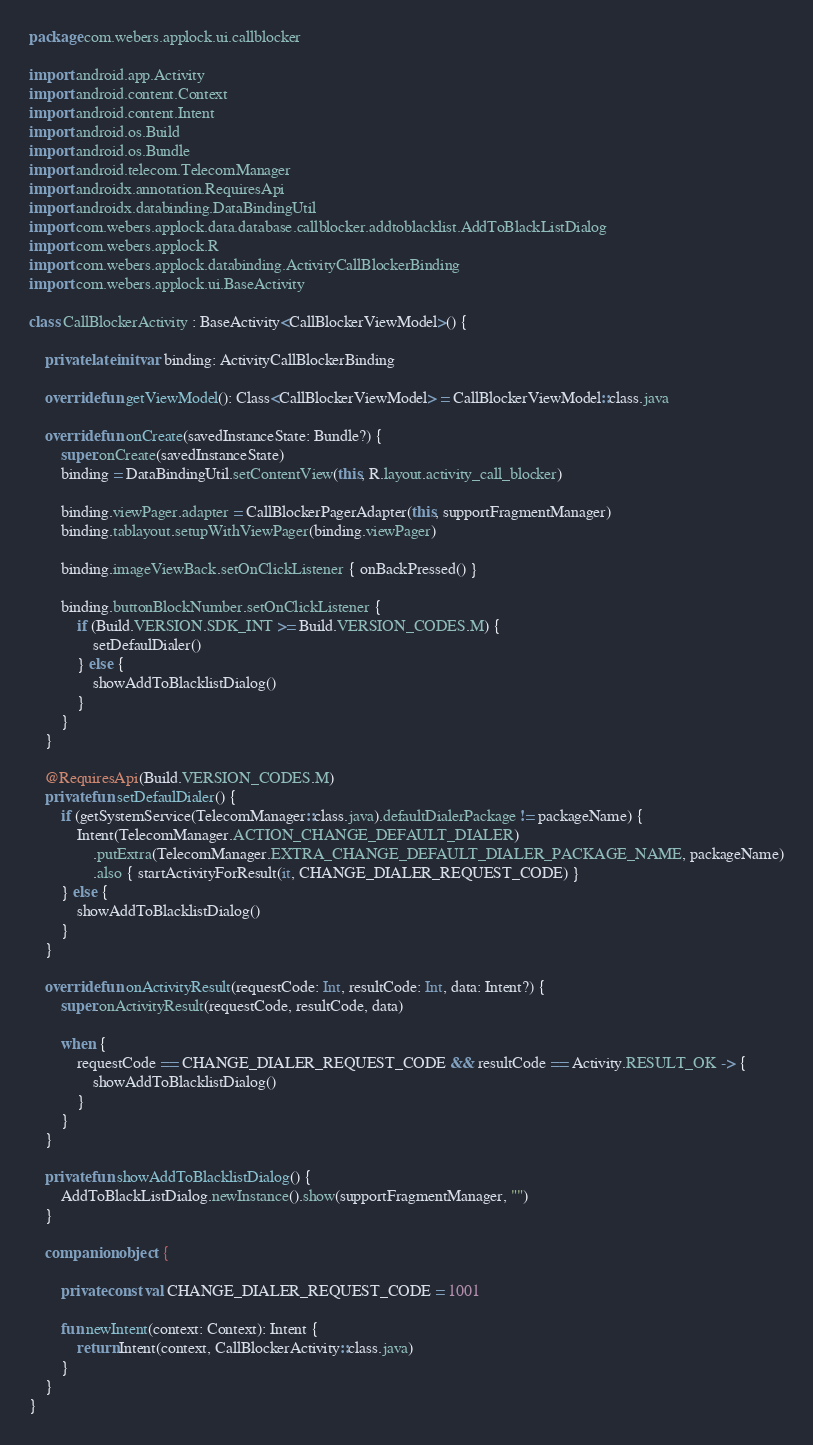<code> <loc_0><loc_0><loc_500><loc_500><_Kotlin_>package com.webers.applock.ui.callblocker

import android.app.Activity
import android.content.Context
import android.content.Intent
import android.os.Build
import android.os.Bundle
import android.telecom.TelecomManager
import androidx.annotation.RequiresApi
import androidx.databinding.DataBindingUtil
import com.webers.applock.data.database.callblocker.addtoblacklist.AddToBlackListDialog
import com.webers.applock.R
import com.webers.applock.databinding.ActivityCallBlockerBinding
import com.webers.applock.ui.BaseActivity

class CallBlockerActivity : BaseActivity<CallBlockerViewModel>() {

    private lateinit var binding: ActivityCallBlockerBinding

    override fun getViewModel(): Class<CallBlockerViewModel> = CallBlockerViewModel::class.java

    override fun onCreate(savedInstanceState: Bundle?) {
        super.onCreate(savedInstanceState)
        binding = DataBindingUtil.setContentView(this, R.layout.activity_call_blocker)

        binding.viewPager.adapter = CallBlockerPagerAdapter(this, supportFragmentManager)
        binding.tablayout.setupWithViewPager(binding.viewPager)

        binding.imageViewBack.setOnClickListener { onBackPressed() }

        binding.buttonBlockNumber.setOnClickListener {
            if (Build.VERSION.SDK_INT >= Build.VERSION_CODES.M) {
                setDefaulDialer()
            } else {
                showAddToBlacklistDialog()
            }
        }
    }

    @RequiresApi(Build.VERSION_CODES.M)
    private fun setDefaulDialer() {
        if (getSystemService(TelecomManager::class.java).defaultDialerPackage != packageName) {
            Intent(TelecomManager.ACTION_CHANGE_DEFAULT_DIALER)
                .putExtra(TelecomManager.EXTRA_CHANGE_DEFAULT_DIALER_PACKAGE_NAME, packageName)
                .also { startActivityForResult(it, CHANGE_DIALER_REQUEST_CODE) }
        } else {
            showAddToBlacklistDialog()
        }
    }

    override fun onActivityResult(requestCode: Int, resultCode: Int, data: Intent?) {
        super.onActivityResult(requestCode, resultCode, data)

        when {
            requestCode == CHANGE_DIALER_REQUEST_CODE && resultCode == Activity.RESULT_OK -> {
                showAddToBlacklistDialog()
            }
        }
    }

    private fun showAddToBlacklistDialog() {
        AddToBlackListDialog.newInstance().show(supportFragmentManager, "")
    }

    companion object {

        private const val CHANGE_DIALER_REQUEST_CODE = 1001

        fun newIntent(context: Context): Intent {
            return Intent(context, CallBlockerActivity::class.java)
        }
    }
}</code> 